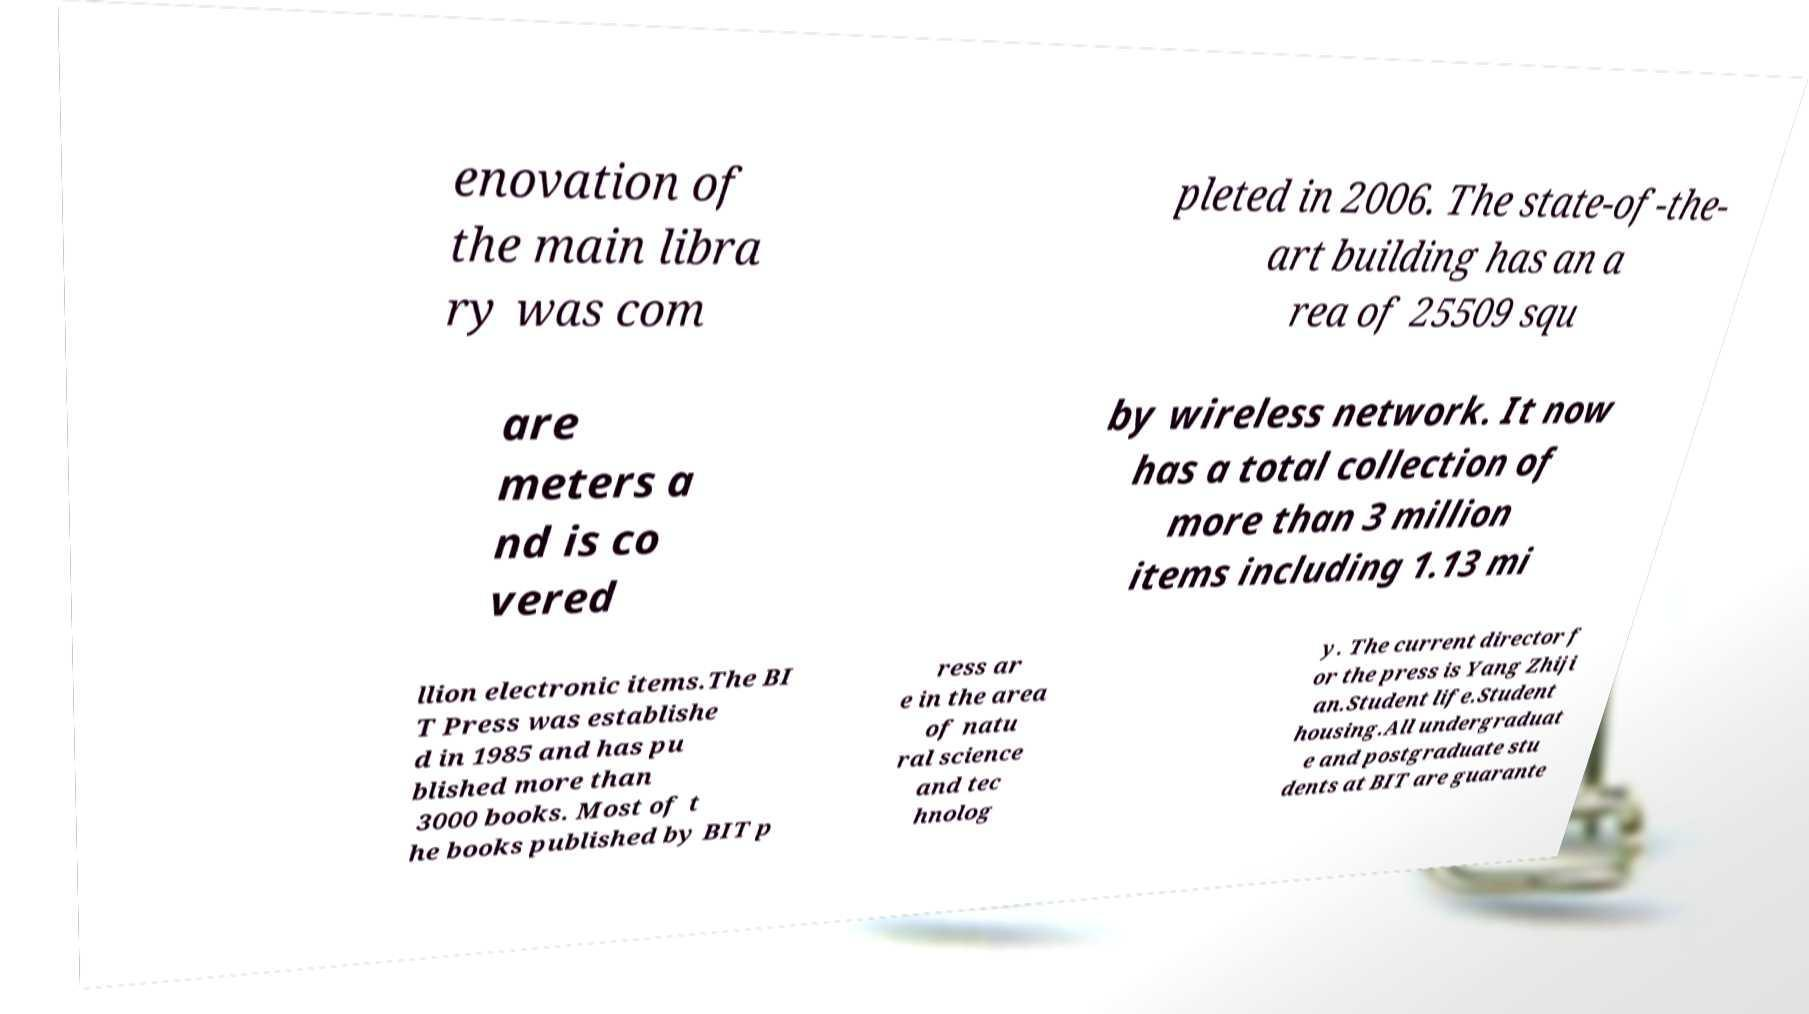I need the written content from this picture converted into text. Can you do that? enovation of the main libra ry was com pleted in 2006. The state-of-the- art building has an a rea of 25509 squ are meters a nd is co vered by wireless network. It now has a total collection of more than 3 million items including 1.13 mi llion electronic items.The BI T Press was establishe d in 1985 and has pu blished more than 3000 books. Most of t he books published by BIT p ress ar e in the area of natu ral science and tec hnolog y. The current director f or the press is Yang Zhiji an.Student life.Student housing.All undergraduat e and postgraduate stu dents at BIT are guarante 